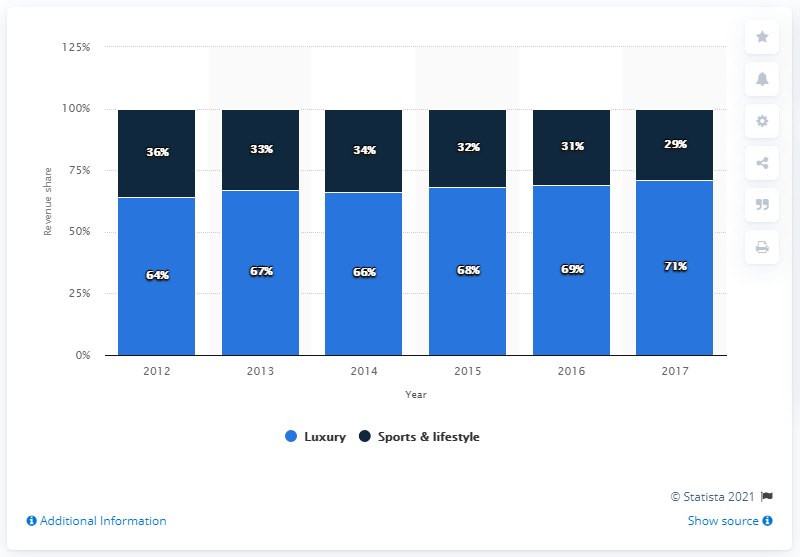Identify some key points in this picture. The average of Luxury is 67.5. In 2016, there was a luxury data that was found out. In 2017, the luxury division of the Kering Group accounted for 71% of the company's total revenue. 